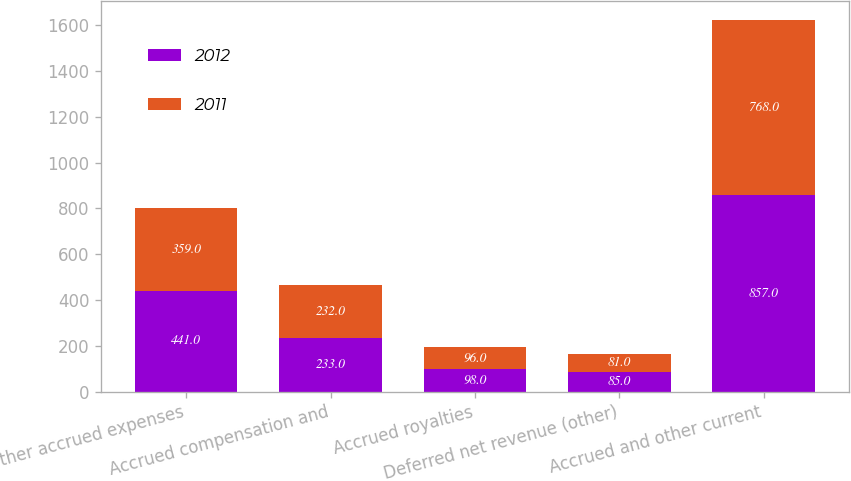<chart> <loc_0><loc_0><loc_500><loc_500><stacked_bar_chart><ecel><fcel>Other accrued expenses<fcel>Accrued compensation and<fcel>Accrued royalties<fcel>Deferred net revenue (other)<fcel>Accrued and other current<nl><fcel>2012<fcel>441<fcel>233<fcel>98<fcel>85<fcel>857<nl><fcel>2011<fcel>359<fcel>232<fcel>96<fcel>81<fcel>768<nl></chart> 